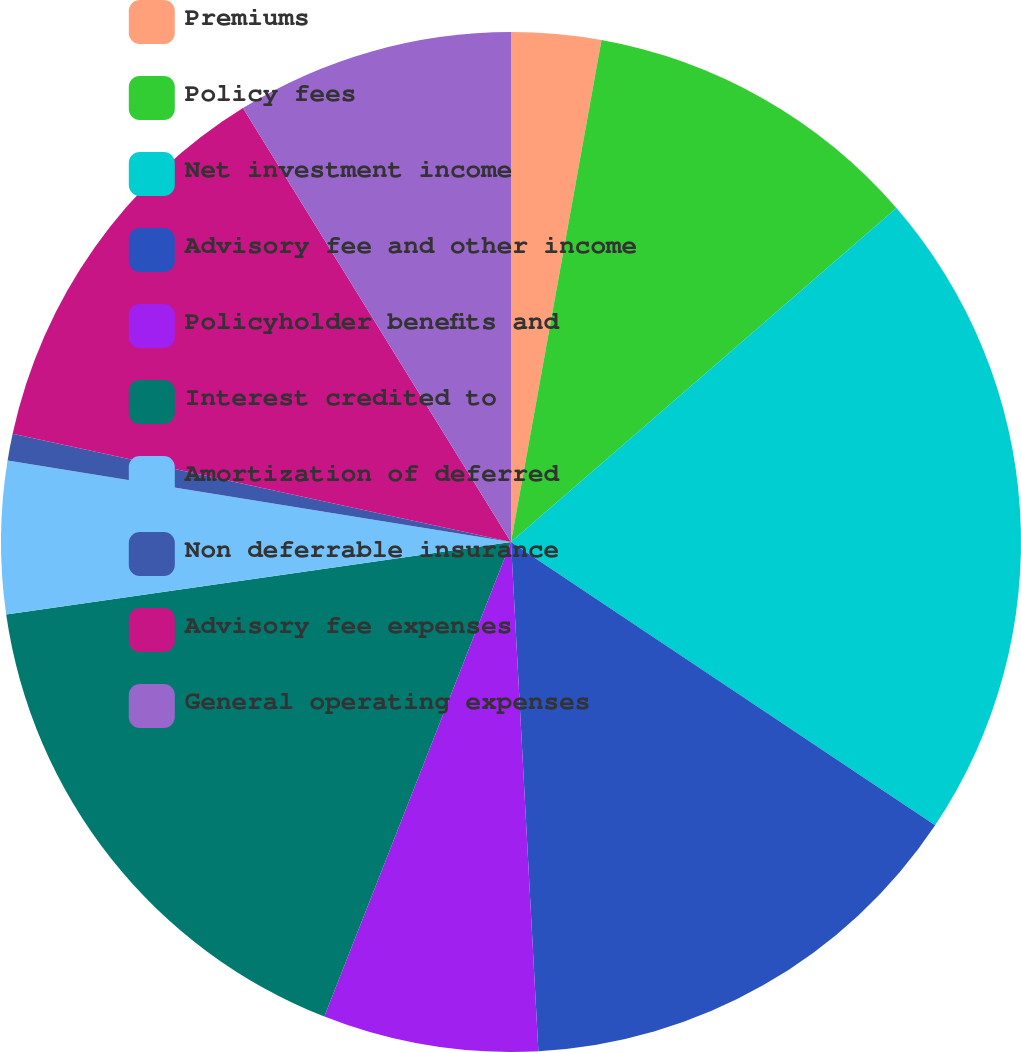Convert chart. <chart><loc_0><loc_0><loc_500><loc_500><pie_chart><fcel>Premiums<fcel>Policy fees<fcel>Net investment income<fcel>Advisory fee and other income<fcel>Policyholder benefits and<fcel>Interest credited to<fcel>Amortization of deferred<fcel>Non deferrable insurance<fcel>Advisory fee expenses<fcel>General operating expenses<nl><fcel>2.84%<fcel>10.8%<fcel>20.74%<fcel>14.78%<fcel>6.82%<fcel>16.77%<fcel>4.83%<fcel>0.85%<fcel>12.79%<fcel>8.81%<nl></chart> 